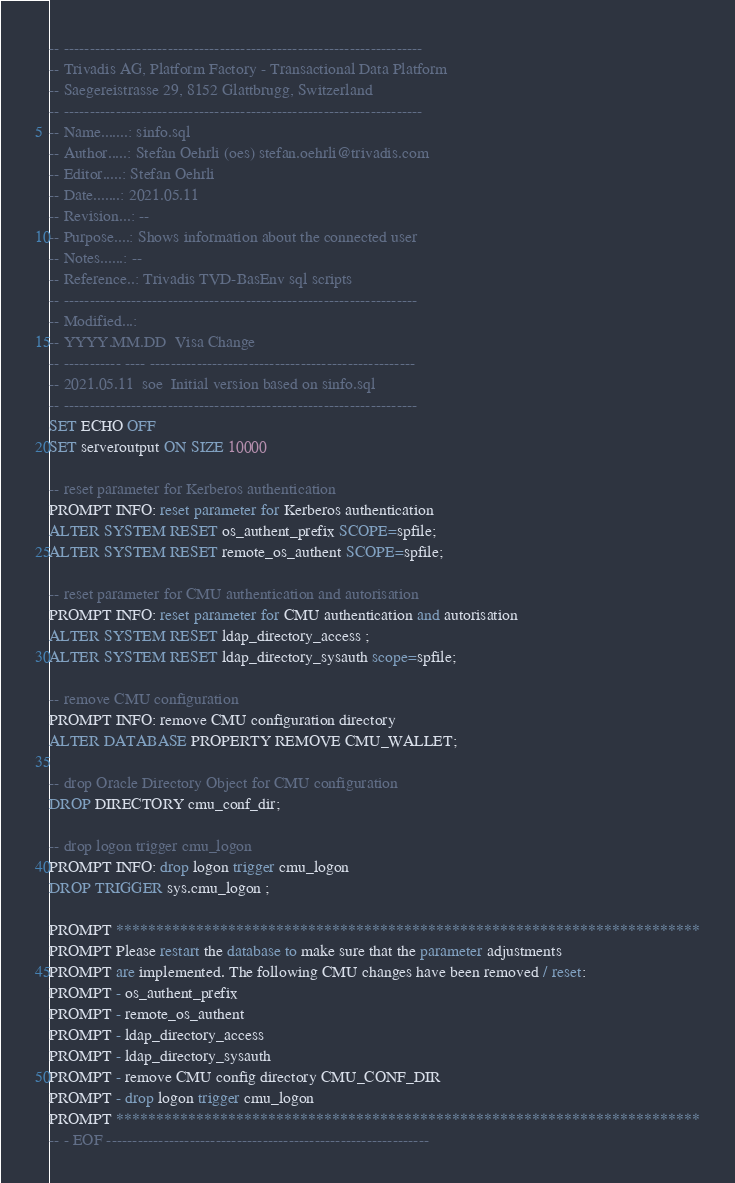Convert code to text. <code><loc_0><loc_0><loc_500><loc_500><_SQL_>-- ---------------------------------------------------------------------
-- Trivadis AG, Platform Factory - Transactional Data Platform
-- Saegereistrasse 29, 8152 Glattbrugg, Switzerland
-- ---------------------------------------------------------------------
-- Name.......: sinfo.sql
-- Author.....: Stefan Oehrli (oes) stefan.oehrli@trivadis.com
-- Editor.....: Stefan Oehrli
-- Date.......: 2021.05.11
-- Revision...: --
-- Purpose....: Shows information about the connected user
-- Notes......: --
-- Reference..: Trivadis TVD-BasEnv sql scripts
-- --------------------------------------------------------------------
-- Modified...:
-- YYYY.MM.DD  Visa Change
-- ----------- ---- ---------------------------------------------------
-- 2021.05.11  soe  Initial version based on sinfo.sql
-- --------------------------------------------------------------------
SET ECHO OFF
SET serveroutput ON SIZE 10000

-- reset parameter for Kerberos authentication
PROMPT INFO: reset parameter for Kerberos authentication 
ALTER SYSTEM RESET os_authent_prefix SCOPE=spfile;
ALTER SYSTEM RESET remote_os_authent SCOPE=spfile;

-- reset parameter for CMU authentication and autorisation
PROMPT INFO: reset parameter for CMU authentication and autorisation
ALTER SYSTEM RESET ldap_directory_access ;
ALTER SYSTEM RESET ldap_directory_sysauth scope=spfile;

-- remove CMU configuration
PROMPT INFO: remove CMU configuration directory
ALTER DATABASE PROPERTY REMOVE CMU_WALLET;

-- drop Oracle Directory Object for CMU configuration
DROP DIRECTORY cmu_conf_dir;

-- drop logon trigger cmu_logon
PROMPT INFO: drop logon trigger cmu_logon
DROP TRIGGER sys.cmu_logon ;

PROMPT *************************************************************************
PROMPT Please restart the database to make sure that the parameter adjustments
PROMPT are implemented. The following CMU changes have been removed / reset:
PROMPT - os_authent_prefix
PROMPT - remote_os_authent
PROMPT - ldap_directory_access
PROMPT - ldap_directory_sysauth
PROMPT - remove CMU config directory CMU_CONF_DIR
PROMPT - drop logon trigger cmu_logon 
PROMPT *************************************************************************
-- - EOF --------------------------------------------------------------
</code> 